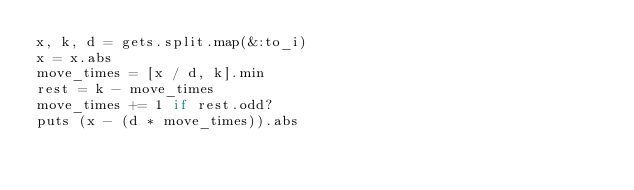<code> <loc_0><loc_0><loc_500><loc_500><_Ruby_>x, k, d = gets.split.map(&:to_i)
x = x.abs
move_times = [x / d, k].min
rest = k - move_times
move_times += 1 if rest.odd?
puts (x - (d * move_times)).abs
</code> 